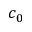Convert formula to latex. <formula><loc_0><loc_0><loc_500><loc_500>c _ { 0 }</formula> 